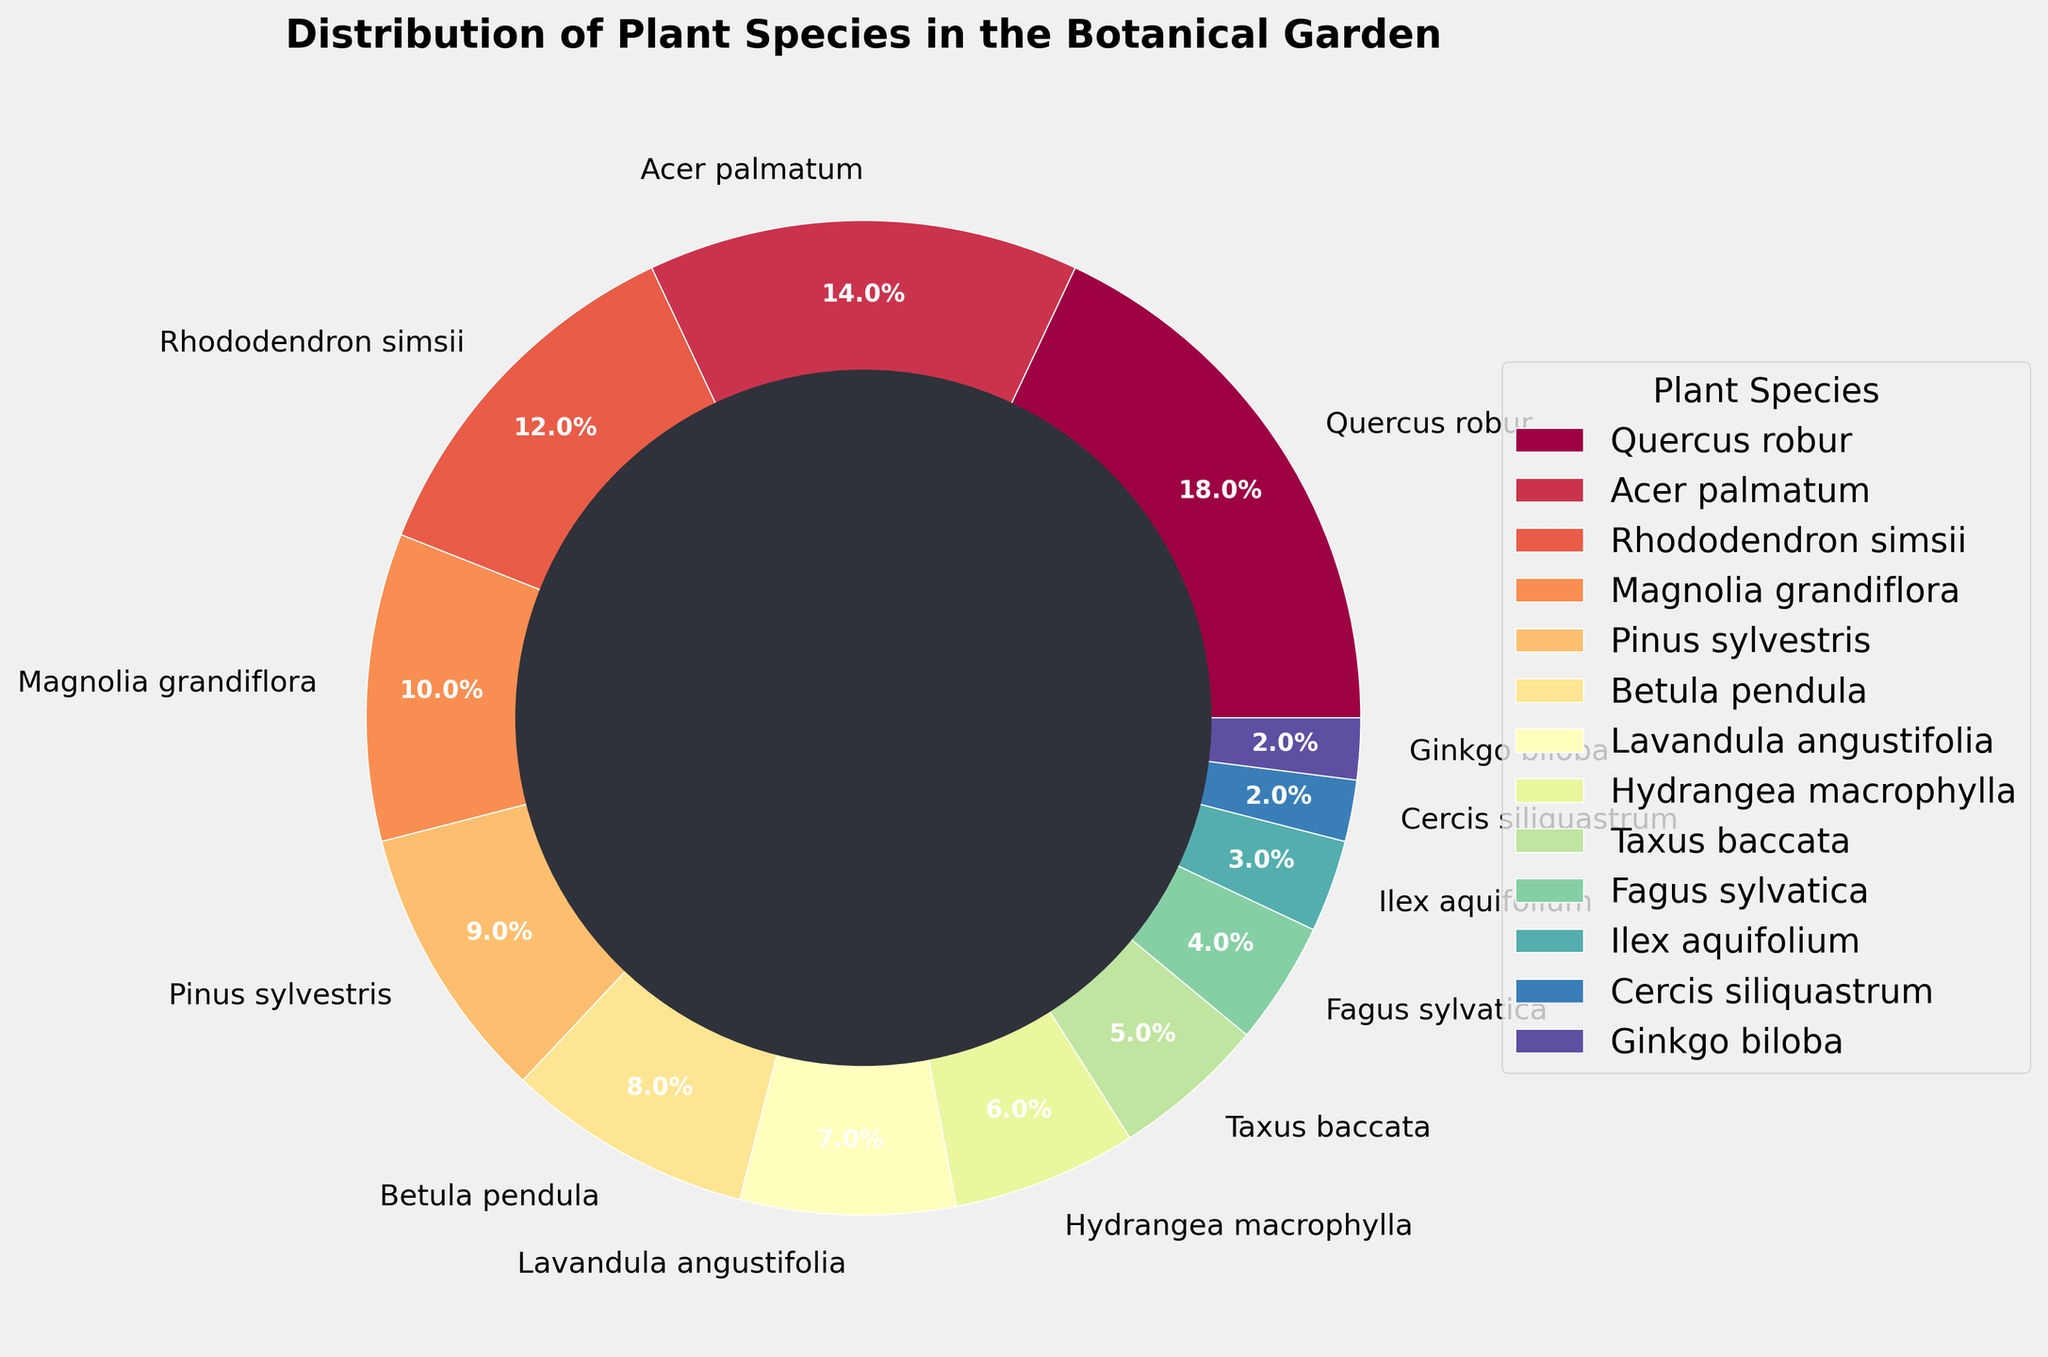What is the most common plant species in the botanical garden? By looking at the pie chart, identify the plant species with the largest slice. The largest slice represents Quercus robur with 18%.
Answer: Quercus robur Which plant species only account for 2% each of the total distribution? Check the pie chart for the slices that represent 2%. Both Cercis siliquastrum and Ginkgo biloba have 2% slices.
Answer: Cercis siliquastrum and Ginkgo biloba What is the total percentage of the three least common plant species? Add the percentages of the three smallest slices. The three least common plant species are Ginkgo biloba (2%), Cercis siliquastrum (2%), and Ilex aquifolium (3%). Their total is 2% + 2% + 3% = 7%.
Answer: 7% How does the percentage of Acer palmatum compare to that of Betula pendula? Locate Acer palmatum and Betula pendula on the pie chart. Acer palmatum has 14%, while Betula pendula has 8%. Therefore, Acer palmatum has a higher percentage than Betula pendula.
Answer: Acer palmatum has a higher percentage What is the combined percentage of Rhododendron simsii and Magnolia grandiflora? Add the percentages of Rhododendron simsii (12%) and Magnolia grandiflora (10%). The combined percentage is 12% + 10% = 22%.
Answer: 22% Which plant species has a wedge that is about half the size of Quercus robur? Look for a species with approximately 9% or close to half of Quercus robur's 18%. Pinus sylvestris has 9%, which is about half of 18%.
Answer: Pinus sylvestris What is the median percentage value of all plant species? List all the percentage values (18, 14, 12, 10, 9, 8, 7, 6, 5, 4, 3, 2, 2) and find the middle value. With 13 data points, the median value is the 7th in ascending order. The median percentage is 7%.
Answer: 7% Which plant species is represented with a blue color in the pie chart? Identify the wedge colored in blue from the pie chart. If the chart follows a standard color map, this may need to be visually confirmed from the plot. In the Spectral colormap, the placement varies, so identify a segment that matches this color visually (often found in plots).
Answer: (Answer would depend on visual confirmation from the plot) What is the difference in percentage between Hydrangea macrophylla and Lavandula angustifolia? Subtract the percentage of Lavandula angustifolia (7%) from the percentage of Hydrangea macrophylla (6%). 7% - 6% = 1%.
Answer: 1% How many plant species are represented with a percentage of less than 5%? Count all the species in the pie chart whose slices represent less than 5%. There are four species with less than 5%: Fagus sylvatica, Ilex aquifolium, Cercis siliquastrum, and Ginkgo biloba.
Answer: Four 